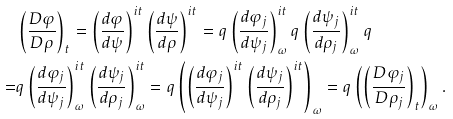<formula> <loc_0><loc_0><loc_500><loc_500>& \left ( \frac { D \varphi } { D \rho } \right ) _ { t } = \left ( \frac { d \varphi } { d \psi } \right ) ^ { i t } \left ( \frac { d \psi } { d \rho } \right ) ^ { i t } = q \left ( \frac { d \varphi _ { j } } { d \psi _ { j } } \right ) ^ { i t } _ { \omega } q \left ( \frac { d \psi _ { j } } { d \rho _ { j } } \right ) ^ { i t } _ { \omega } q \\ = & q \left ( \frac { d \varphi _ { j } } { d \psi _ { j } } \right ) ^ { i t } _ { \omega } \left ( \frac { d \psi _ { j } } { d \rho _ { j } } \right ) ^ { i t } _ { \omega } = q \left ( \left ( \frac { d \varphi _ { j } } { d \psi _ { j } } \right ) ^ { i t } \left ( \frac { d \psi _ { j } } { d \rho _ { j } } \right ) ^ { i t } \right ) _ { \omega } = q \left ( \left ( \frac { D \varphi _ { j } } { D \rho _ { j } } \right ) _ { t } \right ) _ { \omega } .</formula> 